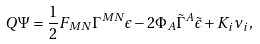<formula> <loc_0><loc_0><loc_500><loc_500>Q \Psi & = \frac { 1 } { 2 } F _ { M N } \Gamma ^ { M N } \epsilon - 2 \Phi _ { A } \tilde { \Gamma } ^ { A } \tilde { \epsilon } + K _ { i } \nu _ { i } ,</formula> 